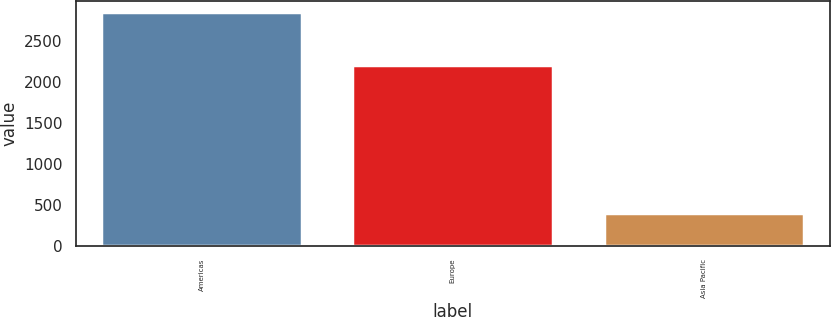<chart> <loc_0><loc_0><loc_500><loc_500><bar_chart><fcel>Americas<fcel>Europe<fcel>Asia Pacific<nl><fcel>2845.6<fcel>2200<fcel>395.1<nl></chart> 